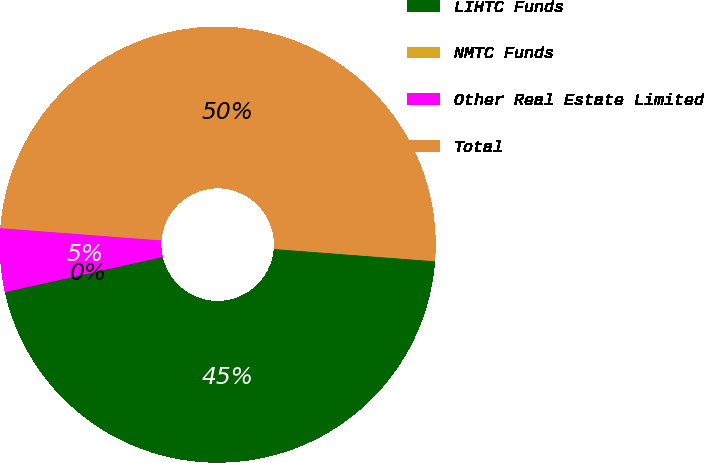Convert chart to OTSL. <chart><loc_0><loc_0><loc_500><loc_500><pie_chart><fcel>LIHTC Funds<fcel>NMTC Funds<fcel>Other Real Estate Limited<fcel>Total<nl><fcel>45.29%<fcel>0.0%<fcel>4.71%<fcel>50.0%<nl></chart> 